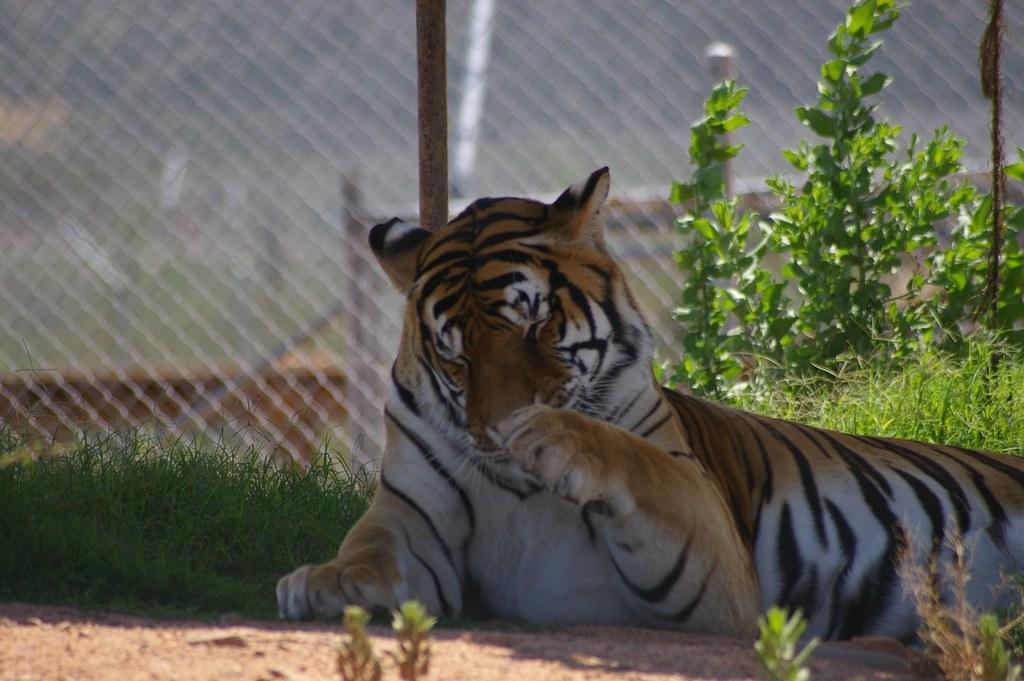Can you describe this image briefly? In this image we can see the tiger is lying on the ground. Here we can see the grass, small plants and the background of the image is slightly blurred, where we can see the fence. 